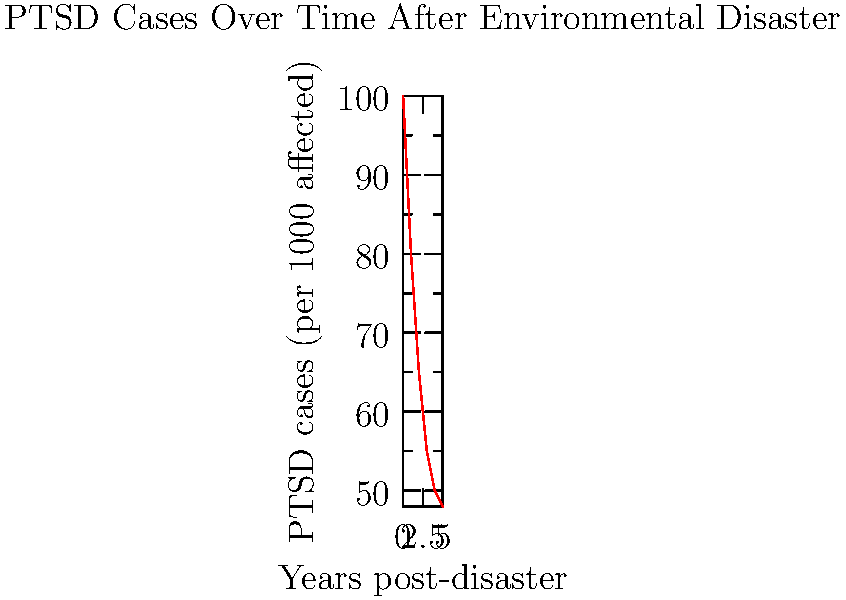Analyze the graph showing the trend of post-disaster PTSD cases over time. What does the shape of the curve suggest about the psychological impact of environmental disasters in the long term, and how might this inform intervention strategies? 1. Initial observation: The graph shows a decreasing trend in PTSD cases over time following an environmental disaster.

2. Rate of change analysis:
   - The steepest decline is observed in the first two years post-disaster.
   - The rate of decline slows down after the second year.
   - The curve starts to flatten out around the fourth and fifth years.

3. Psychological impact interpretation:
   - Immediate aftermath: The high initial number of cases indicates severe acute psychological impact.
   - Early recovery phase (years 1-2): Rapid decrease suggests natural recovery processes and possibly effective early interventions.
   - Later phase (years 3-5): Slower decline indicates persistent cases that may be more resistant to treatment or represent chronic PTSD.

4. Long-term implications:
   - The flattening of the curve suggests that a certain percentage of affected individuals may develop chronic PTSD.
   - This residual level of PTSD cases may represent a long-term psychological burden on the affected population.

5. Intervention strategy implications:
   - Intensive early intervention: Crucial in the first two years when the majority of recovery occurs.
   - Targeted long-term support: Necessary for individuals with persistent symptoms beyond the two-year mark.
   - Preventive measures: Focus on resilience-building in vulnerable populations to potentially reduce the initial spike in PTSD cases.

6. Research considerations:
   - Longitudinal studies are vital to understand the factors contributing to both recovery and persistence of PTSD symptoms.
   - Investigation into the characteristics of individuals who develop chronic PTSD could inform more effective interventions.
Answer: The curve suggests rapid initial recovery followed by persistent chronic cases, implying the need for intensive early interventions and targeted long-term support for resistant cases. 